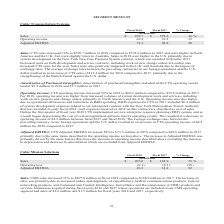According to Cubic's financial document, What is the percentage increase in CTS sales in 2018? According to the financial document, 16%. The relevant text states: "ted EBITDA 73.3 48.8 50 Sales: CTS sales increased 16% to $670.7 million in 2018 compared to $578.6 million in 2017 and were higher in North America and th..." Also, What resulted in a higher operating income? increased volumes of system development work and services, including work on new projects and change orders, primarily in North America and the U.K. Operating income was also higher due to operational efficiencies and reductions in R&D spending. The document states: "2017. For 2018, operating income was higher from increased volumes of system development work and services, including work on new projects and change ..." Also, What is the Sales for 2018? According to the financial document, $ 670.7 (in millions). The relevant text states: "Sales $ 670.7 $ 578.6 16 % Operating income 60.4 39.8 52..." Additionally, In which year was the amortization of purchased intangibles included in the CTS operating results lower? According to the financial document, 2018. The relevant text states: "Fiscal 2018 Fiscal 2017 % Change (in millions)..." Also, can you calculate: What is the change in CTS adjusted EBITDA? Based on the calculation: 73.3-48.8, the result is 24.5 (in millions). This is based on the information: "Adjusted EBITDA 73.3 48.8 50 Sales: CTS sales increased 16% to $670.7 million in 2018 compared to $578.6 million in 2017 and Adjusted EBITDA 73.3 48.8 50 Sales: CTS sales increased 16% to $670.7 milli..." The key data points involved are: 48.8, 73.3. Also, can you calculate: What is the average operating income in 2017 and 2018? To answer this question, I need to perform calculations using the financial data. The calculation is: (60.4+39.8)/2, which equals 50.1 (in millions). This is based on the information: "Sales $ 670.7 $ 578.6 16 % Operating income 60.4 39.8 52 Sales $ 670.7 $ 578.6 16 % Operating income 60.4 39.8 52..." The key data points involved are: 39.8, 60.4. 